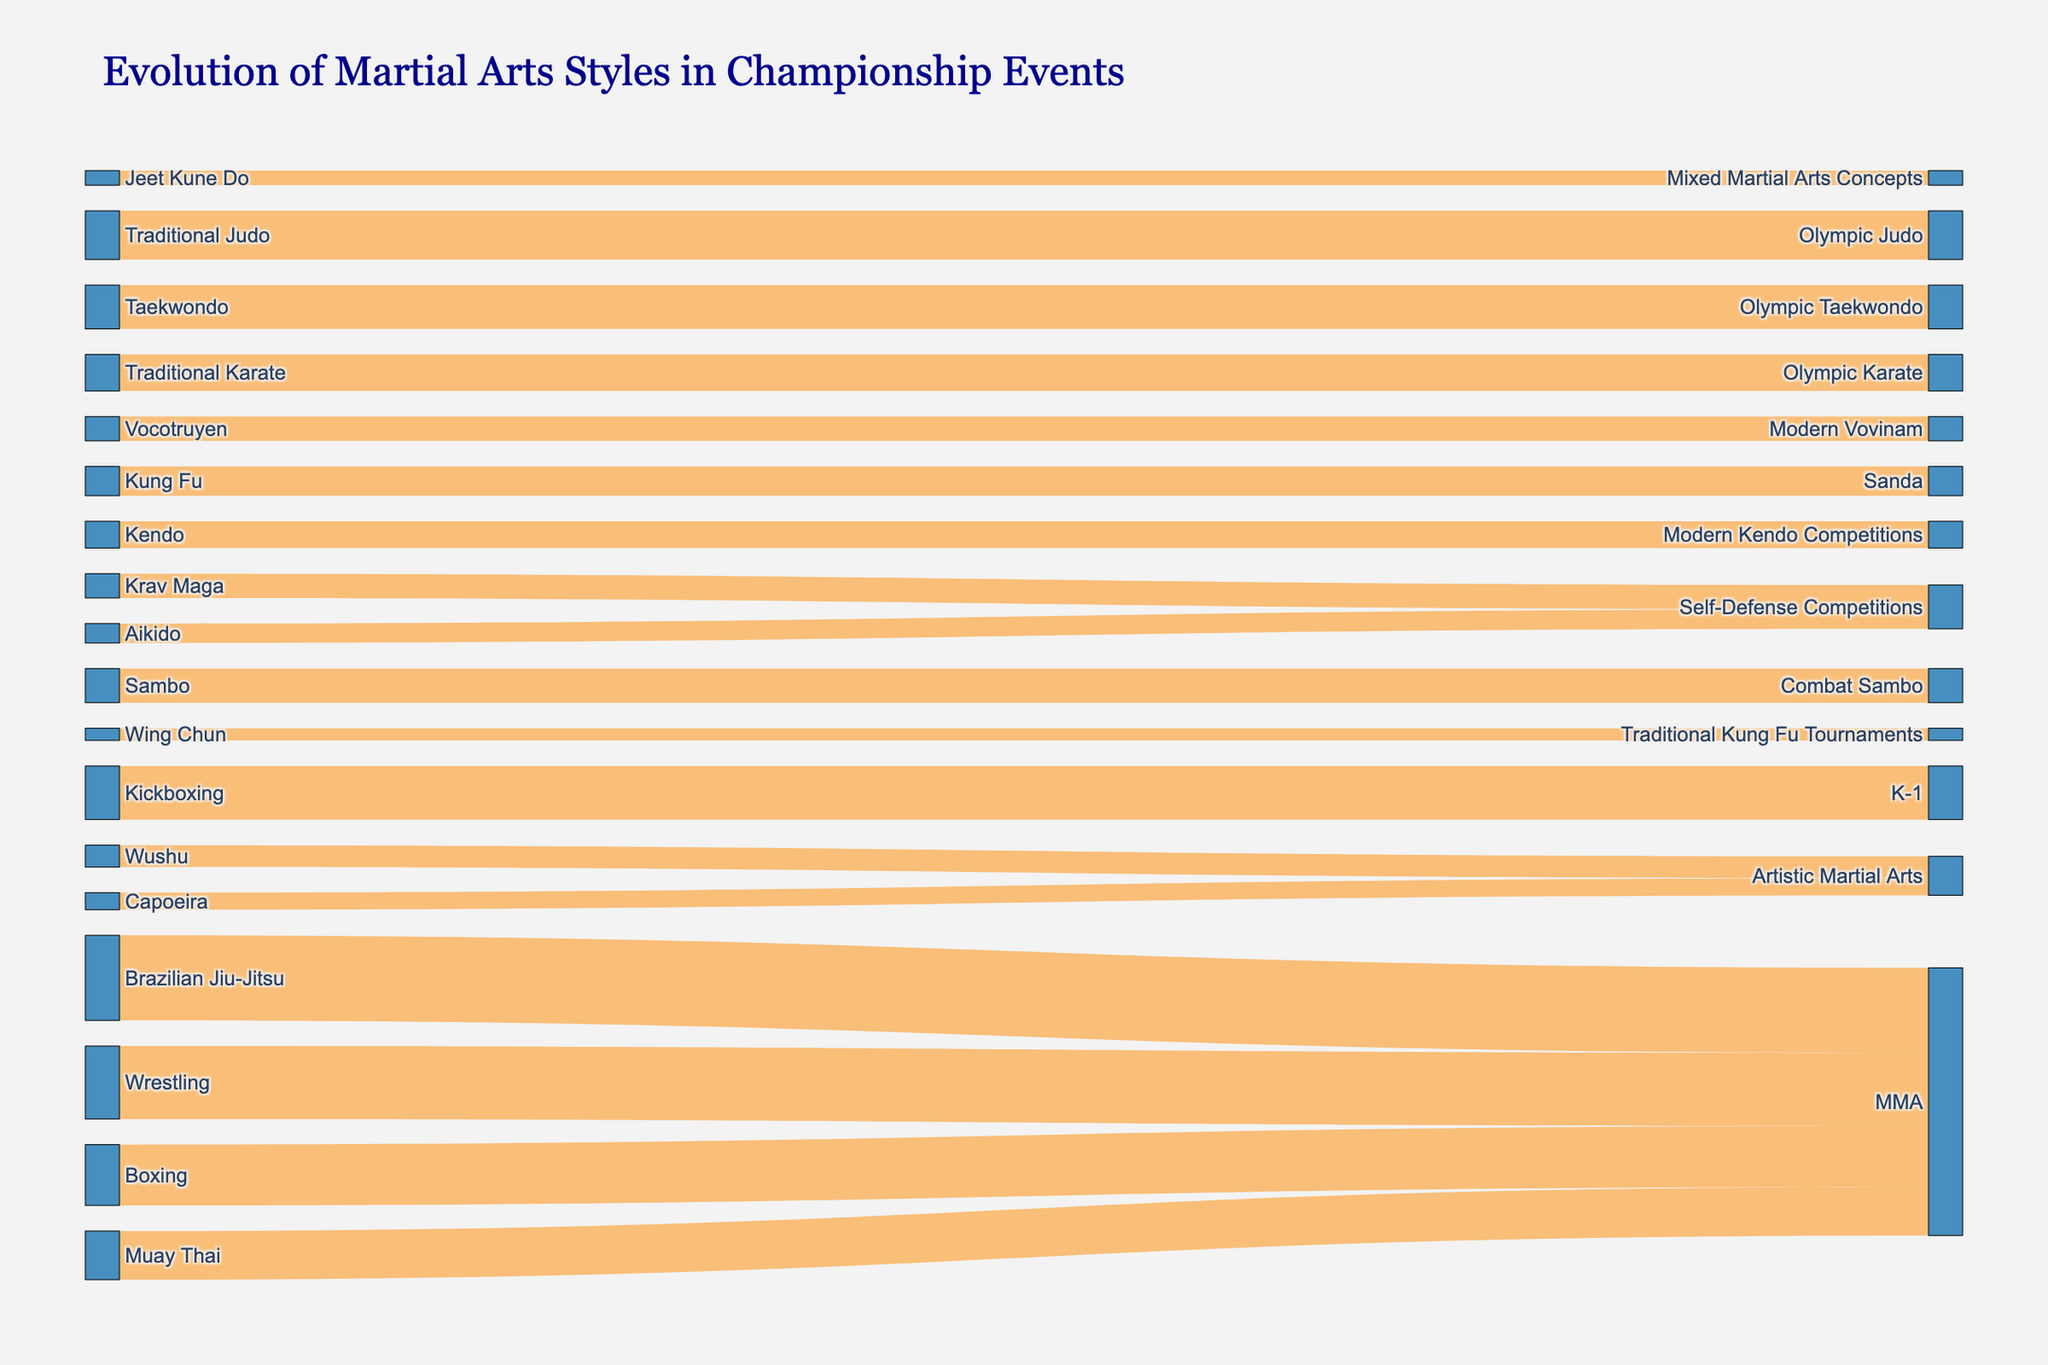What is the title of the figure? The title is usually at the top of the figure and gives an overview of what the diagram represents. In this case, it is,"Evolution of Martial Arts Styles in Championship Events."
Answer: Evolution of Martial Arts Styles in Championship Events Which martial art style has the highest value in its target category? To find this, look for the highest value in the links between sources and targets. The highest value is 35, from Brazilian Jiu-Jitsu to MMA.
Answer: Brazilian Jiu-Jitsu to MMA How many martial art styles evolve into 'MMA' as their target category? Count the number of distinct source styles leading to "MMA" as the target in the diagram. The sources leading to MMA are Boxing, Wrestling, Brazilian Jiu-Jitsu, and Muay Thai.
Answer: 4 What's the combined total value for all styles evolving into Olympic categories? Sum the values for all styles leading to Olympic categories (Olympic Karate, Olympic Judo, and Olympic Taekwondo). 15 (Traditional Karate) + 20 (Traditional Judo) + 18 (Taekwondo) = 53
Answer: 53 Which source style evolves into the most number of distinct target categories? Count the number of unique target categories each source style evolves into. MMA has multiple source styles, but each source style evolves into only one target. Verify this for each source, but in this case, no style evolves into more than one target.
Answer: None How much higher is the value for Muay Thai evolving into MMA compared to Vocotruyen evolving into Modern Vovinam? Subtract the values of Vocotruyen to Modern Vovinam from Muay Thai to MMA. 20 (Muay Thai to MMA) - 10 (Vocotruyen to Modern Vovinam) = 10
Answer: 10 Which target category receives the least number of styles from different sources? Count the number of unique sources contributing to each target category. "Traditional Kung Fu Tournaments" has only one source, Wing Chun.
Answer: Traditional Kung Fu Tournaments How many distinct target categories are there in the figure? The target categories are the unique values in the "Target" column. Count these unique values. There are 14 distinct target categories.
Answer: 14 What is the shortest path (minimum value) from the source to any target? Identify the smallest value in the links between sources and targets. The smallest value is 5, from Wing Chun to Traditional Kung Fu Tournaments.
Answer: Wing Chun to Traditional Kung Fu Tournaments 